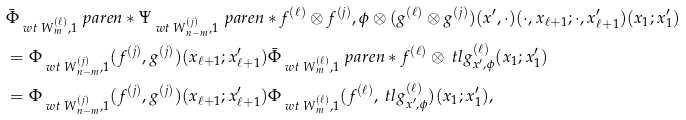<formula> <loc_0><loc_0><loc_500><loc_500>& \bar { \Phi } _ { \ w t { \ W } _ { m } ^ { ( \ell ) } , 1 } \ p a r e n * { \Psi _ { \ w t { \ W } _ { n - m } ^ { ( j ) } , 1 } \ p a r e n * { f ^ { ( \ell ) } \otimes f ^ { ( j ) } , \phi \otimes ( g ^ { ( \ell ) } \otimes g ^ { ( j ) } ) ( x ^ { \prime } , \cdot ) } ( \cdot , x _ { \ell + 1 } ; \cdot , x _ { \ell + 1 } ^ { \prime } ) } ( x _ { 1 } ; x _ { 1 } ^ { \prime } ) \\ & = \Phi _ { \ w t { \ W } _ { n - m } ^ { ( j ) } , 1 } ( f ^ { ( j ) } , g ^ { ( j ) } ) ( x _ { \ell + 1 } ; x _ { \ell + 1 } ^ { \prime } ) \bar { \Phi } _ { \ w t { \ W } _ { m } ^ { ( \ell ) } , 1 } \ p a r e n * { f ^ { ( \ell ) } \otimes \ t l { g } _ { x ^ { \prime } , \phi } ^ { ( \ell ) } } ( x _ { 1 } ; x _ { 1 } ^ { \prime } ) \\ & = \Phi _ { \ w t { \ W } _ { n - m } ^ { ( j ) } , 1 } ( f ^ { ( j ) } , g ^ { ( j ) } ) ( x _ { \ell + 1 } ; x _ { \ell + 1 } ^ { \prime } ) \Phi _ { \ w t { \ W } _ { m } ^ { ( \ell ) } , 1 } ( f ^ { ( \ell ) } , \ t l { g } _ { x ^ { \prime } , \phi } ^ { ( \ell ) } ) ( x _ { 1 } ; x _ { 1 } ^ { \prime } ) ,</formula> 